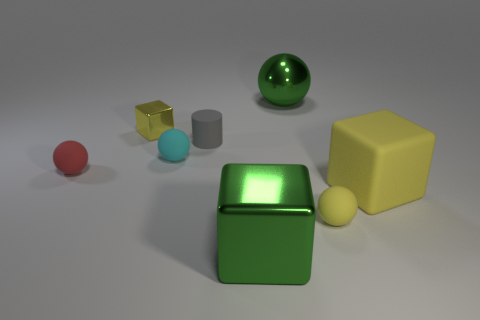Subtract all blue spheres. Subtract all red cylinders. How many spheres are left? 4 Add 1 cubes. How many objects exist? 9 Subtract all cubes. How many objects are left? 5 Subtract 1 green spheres. How many objects are left? 7 Subtract all small red spheres. Subtract all large green shiny balls. How many objects are left? 6 Add 4 tiny red rubber spheres. How many tiny red rubber spheres are left? 5 Add 8 small cyan balls. How many small cyan balls exist? 9 